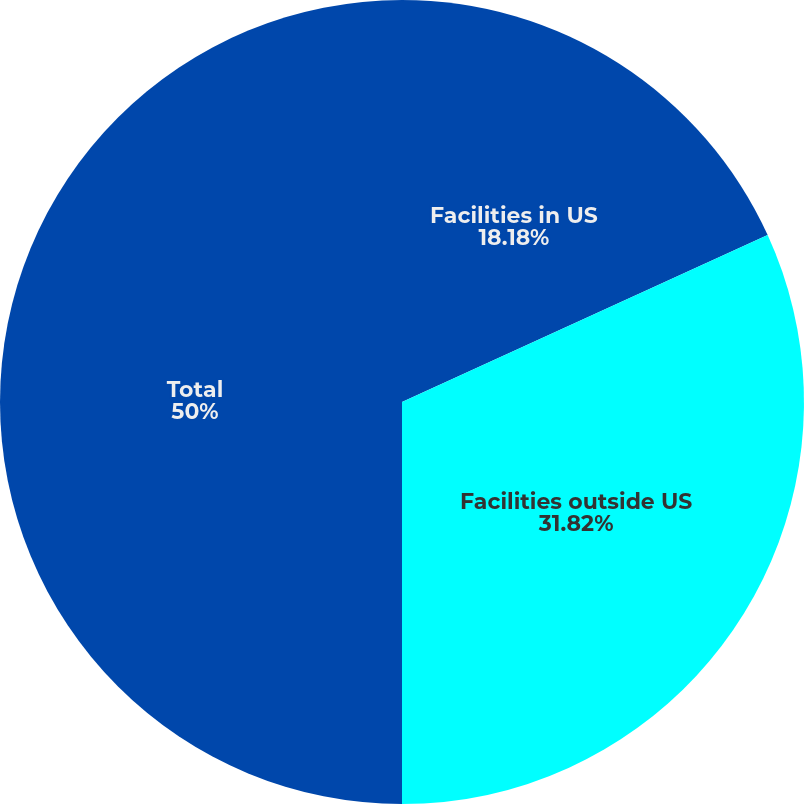Convert chart. <chart><loc_0><loc_0><loc_500><loc_500><pie_chart><fcel>Facilities in US<fcel>Facilities outside US<fcel>Total<nl><fcel>18.18%<fcel>31.82%<fcel>50.0%<nl></chart> 